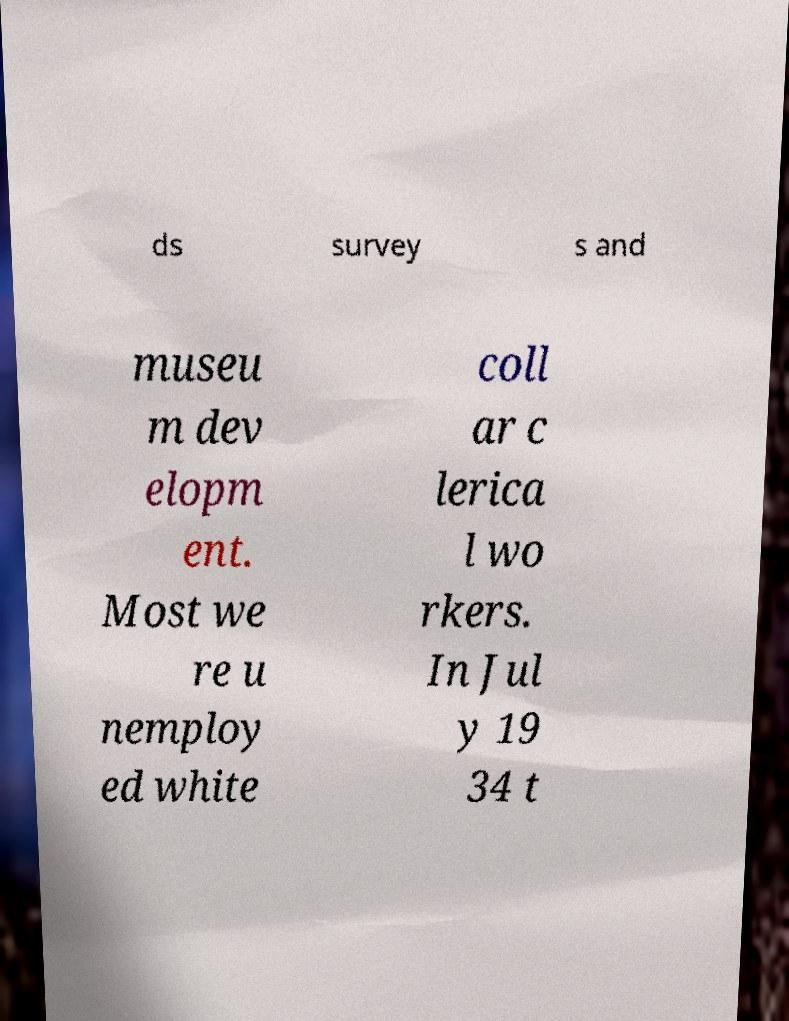Could you assist in decoding the text presented in this image and type it out clearly? ds survey s and museu m dev elopm ent. Most we re u nemploy ed white coll ar c lerica l wo rkers. In Jul y 19 34 t 